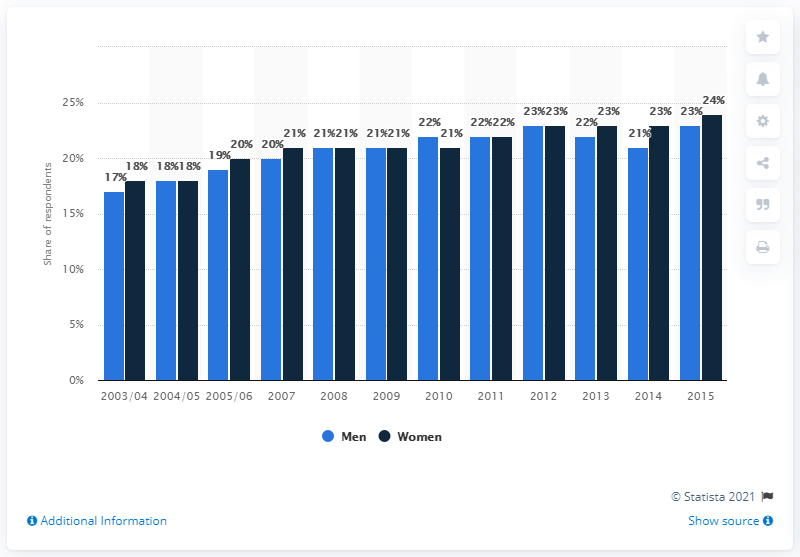Mention a couple of crucial points in this snapshot. In 2011, obesity affected both men and women, with a percentage of 22% of the population being obese. In 2011, approximately 22% of both men and women in the United States were obese. 